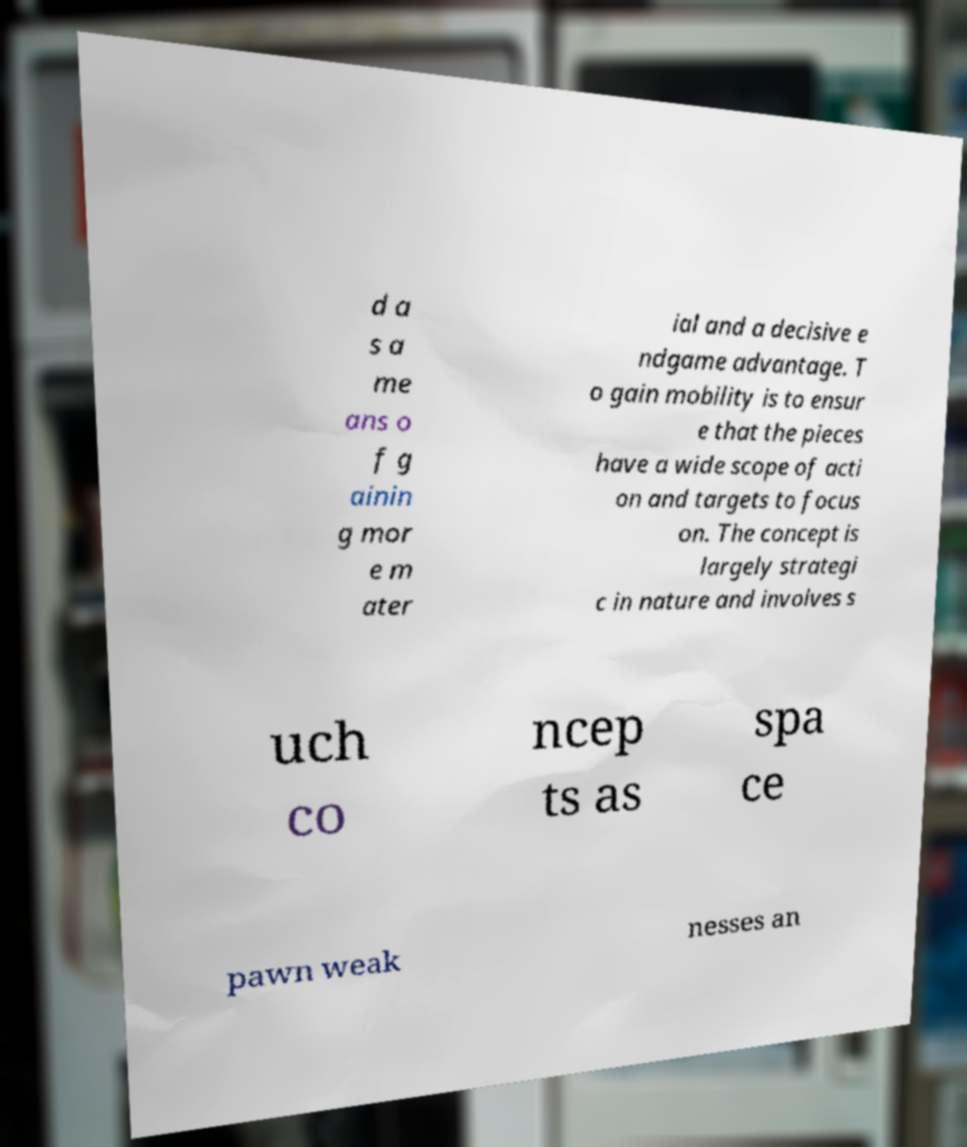Can you accurately transcribe the text from the provided image for me? d a s a me ans o f g ainin g mor e m ater ial and a decisive e ndgame advantage. T o gain mobility is to ensur e that the pieces have a wide scope of acti on and targets to focus on. The concept is largely strategi c in nature and involves s uch co ncep ts as spa ce pawn weak nesses an 